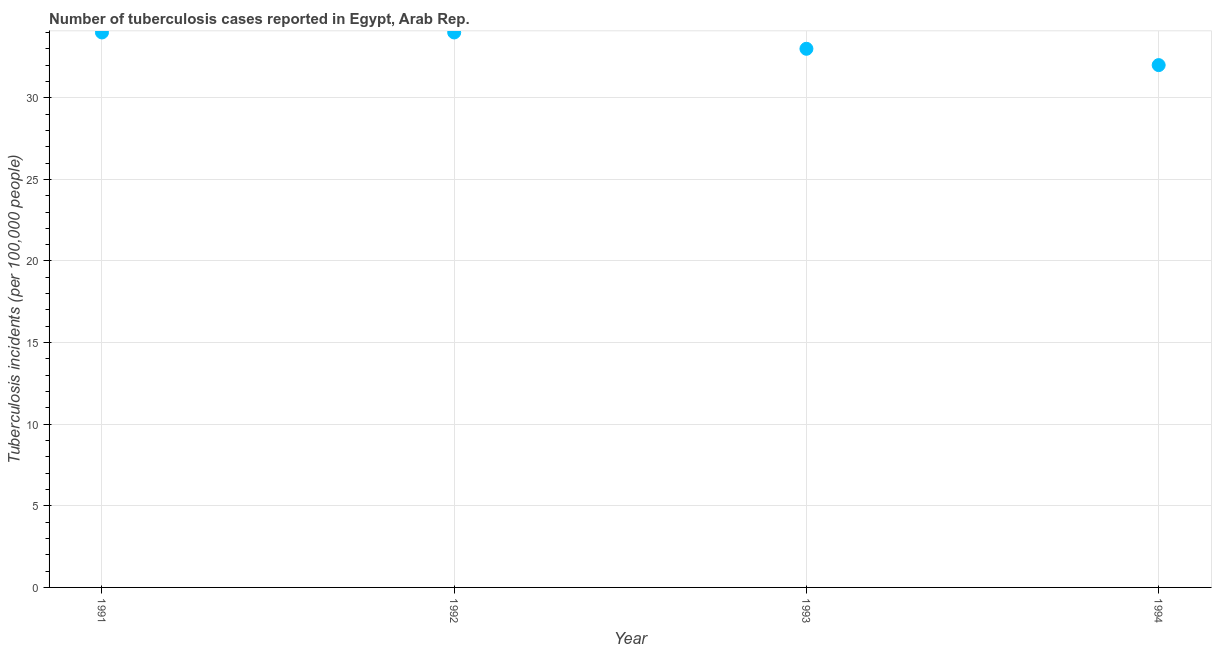What is the number of tuberculosis incidents in 1994?
Your answer should be very brief. 32. Across all years, what is the maximum number of tuberculosis incidents?
Make the answer very short. 34. Across all years, what is the minimum number of tuberculosis incidents?
Your response must be concise. 32. What is the sum of the number of tuberculosis incidents?
Keep it short and to the point. 133. What is the difference between the number of tuberculosis incidents in 1992 and 1993?
Provide a succinct answer. 1. What is the average number of tuberculosis incidents per year?
Offer a terse response. 33.25. What is the median number of tuberculosis incidents?
Provide a short and direct response. 33.5. In how many years, is the number of tuberculosis incidents greater than 13 ?
Offer a very short reply. 4. What is the ratio of the number of tuberculosis incidents in 1991 to that in 1993?
Your answer should be very brief. 1.03. Is the number of tuberculosis incidents in 1991 less than that in 1993?
Your answer should be compact. No. Is the sum of the number of tuberculosis incidents in 1992 and 1994 greater than the maximum number of tuberculosis incidents across all years?
Ensure brevity in your answer.  Yes. What is the difference between the highest and the lowest number of tuberculosis incidents?
Offer a terse response. 2. How many years are there in the graph?
Keep it short and to the point. 4. Does the graph contain any zero values?
Make the answer very short. No. What is the title of the graph?
Offer a terse response. Number of tuberculosis cases reported in Egypt, Arab Rep. What is the label or title of the X-axis?
Your answer should be compact. Year. What is the label or title of the Y-axis?
Provide a short and direct response. Tuberculosis incidents (per 100,0 people). What is the Tuberculosis incidents (per 100,000 people) in 1991?
Keep it short and to the point. 34. What is the Tuberculosis incidents (per 100,000 people) in 1993?
Ensure brevity in your answer.  33. What is the difference between the Tuberculosis incidents (per 100,000 people) in 1992 and 1993?
Offer a very short reply. 1. What is the difference between the Tuberculosis incidents (per 100,000 people) in 1993 and 1994?
Provide a short and direct response. 1. What is the ratio of the Tuberculosis incidents (per 100,000 people) in 1991 to that in 1992?
Provide a succinct answer. 1. What is the ratio of the Tuberculosis incidents (per 100,000 people) in 1991 to that in 1993?
Make the answer very short. 1.03. What is the ratio of the Tuberculosis incidents (per 100,000 people) in 1991 to that in 1994?
Your answer should be very brief. 1.06. What is the ratio of the Tuberculosis incidents (per 100,000 people) in 1992 to that in 1993?
Provide a short and direct response. 1.03. What is the ratio of the Tuberculosis incidents (per 100,000 people) in 1992 to that in 1994?
Give a very brief answer. 1.06. What is the ratio of the Tuberculosis incidents (per 100,000 people) in 1993 to that in 1994?
Give a very brief answer. 1.03. 